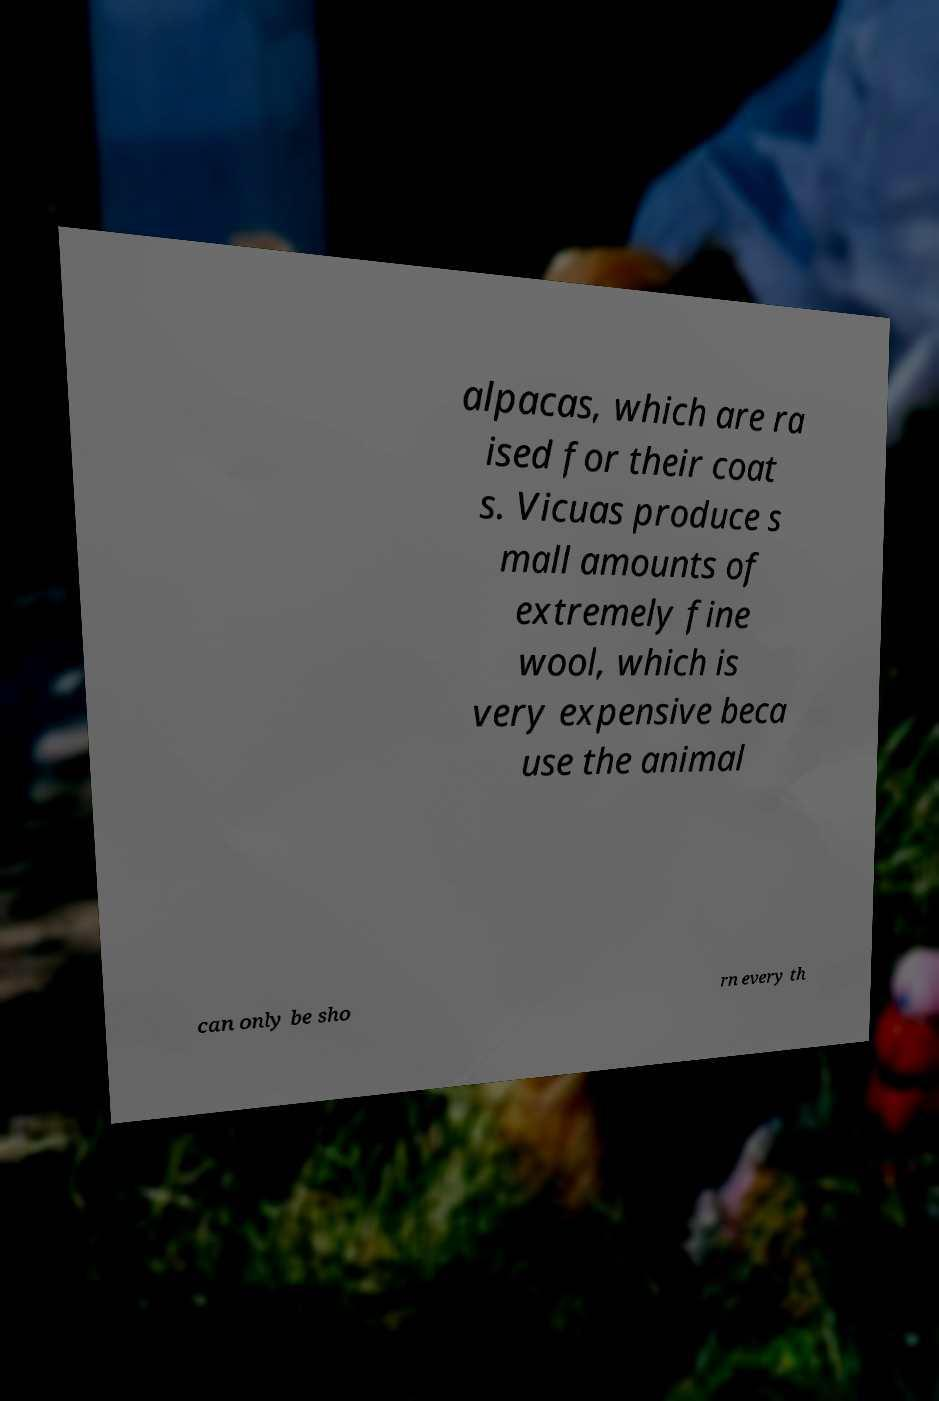Please read and relay the text visible in this image. What does it say? alpacas, which are ra ised for their coat s. Vicuas produce s mall amounts of extremely fine wool, which is very expensive beca use the animal can only be sho rn every th 